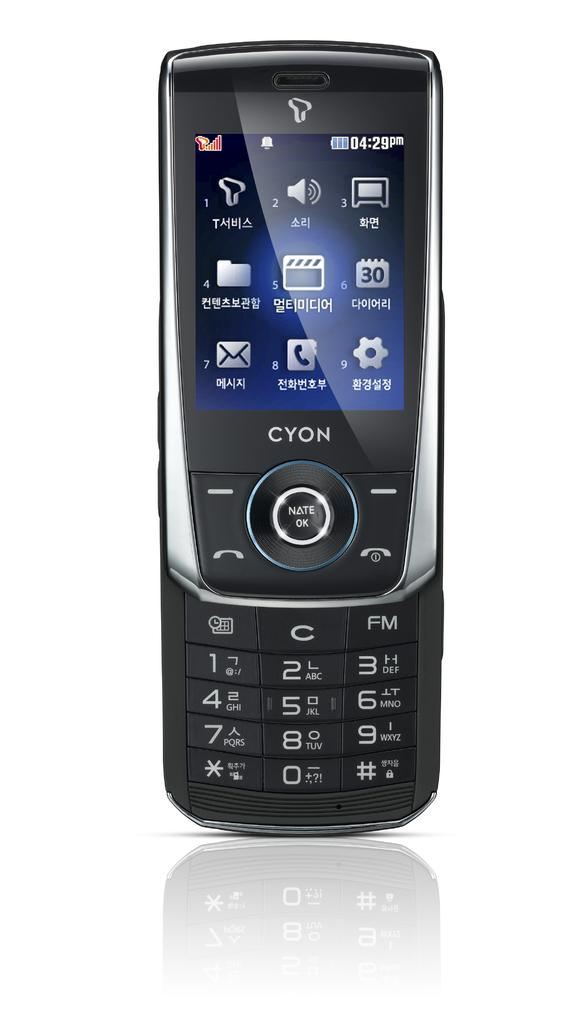Provide a one-sentence caption for the provided image. A cell phone that slides up to reveal the number pad. 